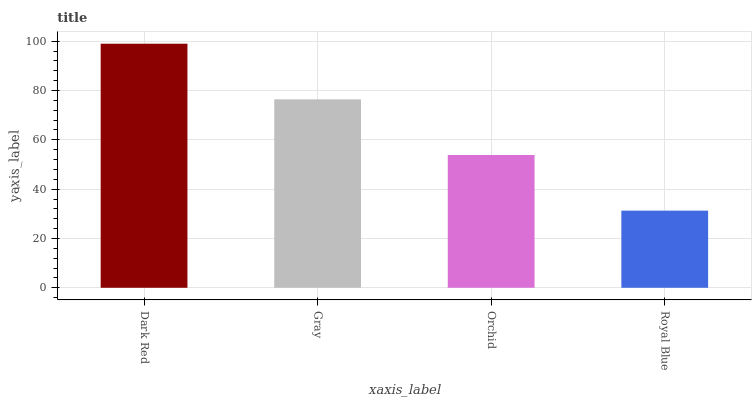Is Royal Blue the minimum?
Answer yes or no. Yes. Is Dark Red the maximum?
Answer yes or no. Yes. Is Gray the minimum?
Answer yes or no. No. Is Gray the maximum?
Answer yes or no. No. Is Dark Red greater than Gray?
Answer yes or no. Yes. Is Gray less than Dark Red?
Answer yes or no. Yes. Is Gray greater than Dark Red?
Answer yes or no. No. Is Dark Red less than Gray?
Answer yes or no. No. Is Gray the high median?
Answer yes or no. Yes. Is Orchid the low median?
Answer yes or no. Yes. Is Orchid the high median?
Answer yes or no. No. Is Royal Blue the low median?
Answer yes or no. No. 